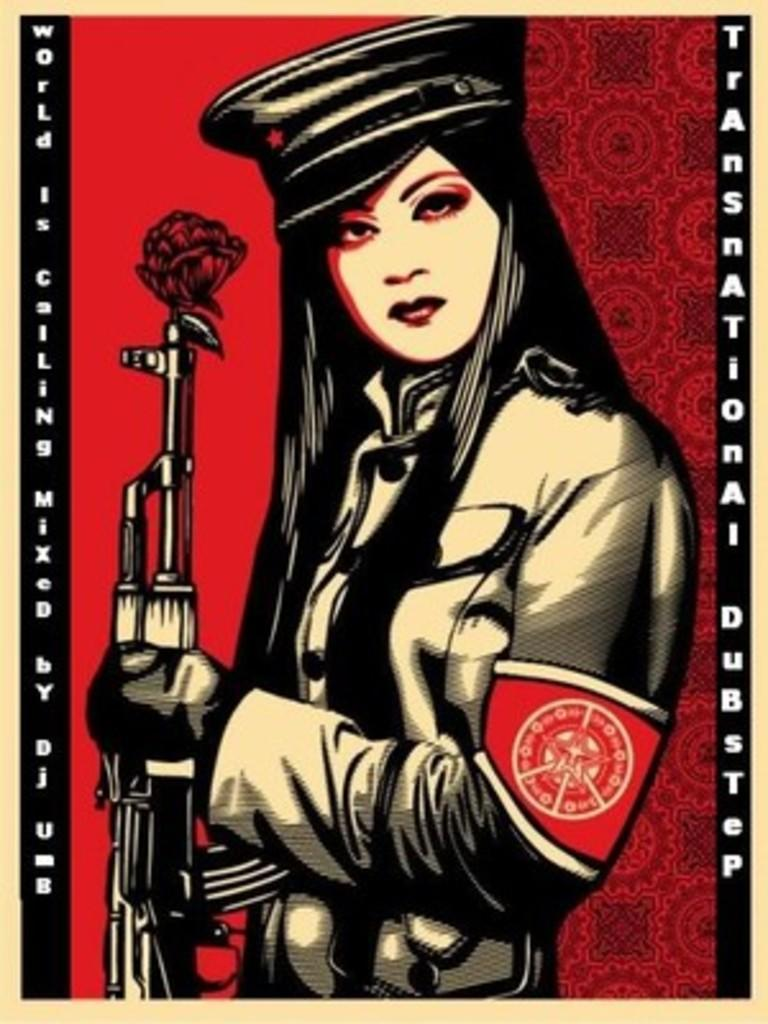What is the girl in the image holding? The girl is holding a gun in the image. What can be seen on the gun? There is a depiction of a flower on the gun. Is there any text present in the image? Yes, there is writing on both sides of the image. What news is being reported on the pan in the image? There is no pan present in the image. 